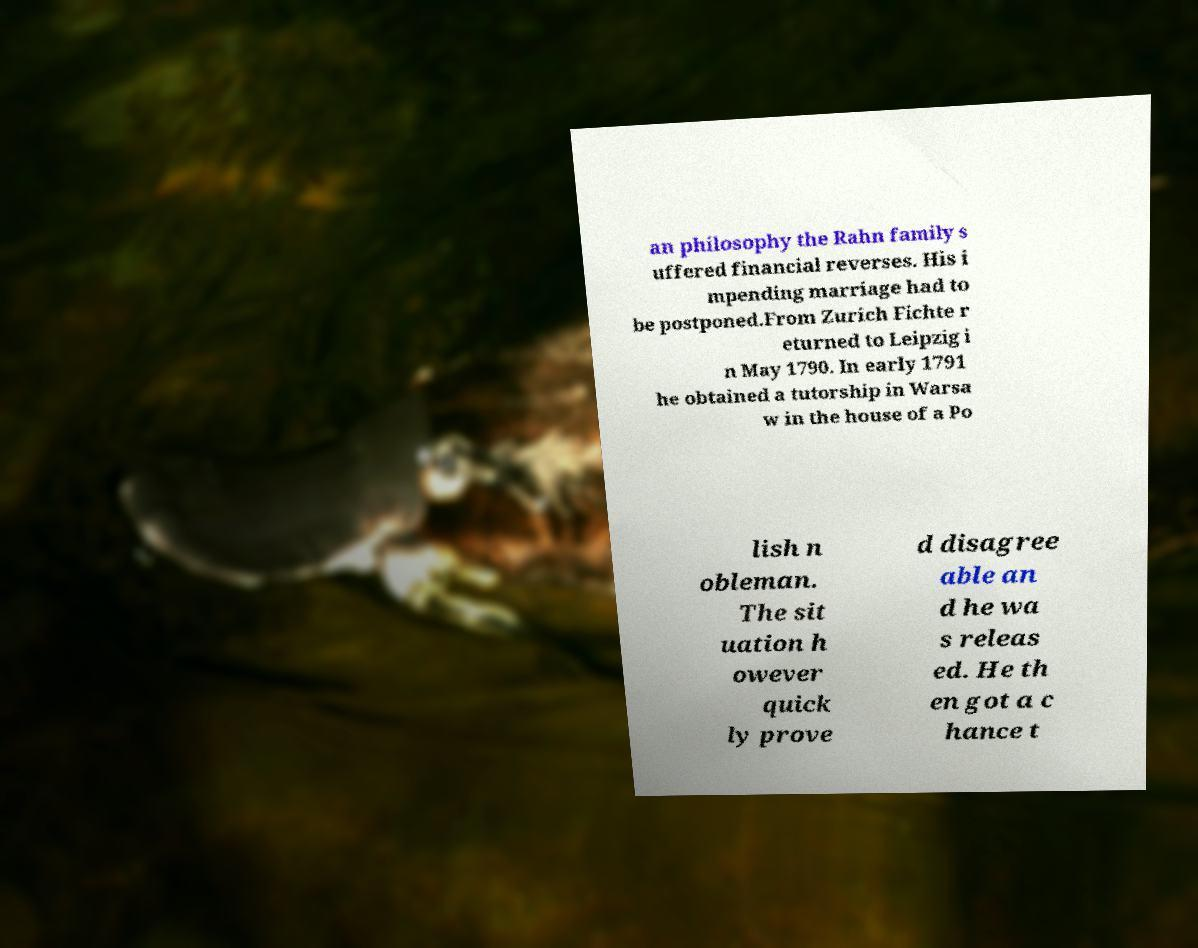What messages or text are displayed in this image? I need them in a readable, typed format. an philosophy the Rahn family s uffered financial reverses. His i mpending marriage had to be postponed.From Zurich Fichte r eturned to Leipzig i n May 1790. In early 1791 he obtained a tutorship in Warsa w in the house of a Po lish n obleman. The sit uation h owever quick ly prove d disagree able an d he wa s releas ed. He th en got a c hance t 